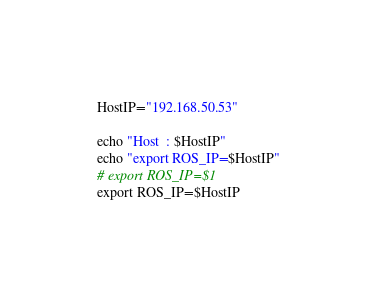Convert code to text. <code><loc_0><loc_0><loc_500><loc_500><_Bash_>HostIP="192.168.50.53"

echo "Host  : $HostIP"
echo "export ROS_IP=$HostIP"
# export ROS_IP=$1
export ROS_IP=$HostIP
</code> 